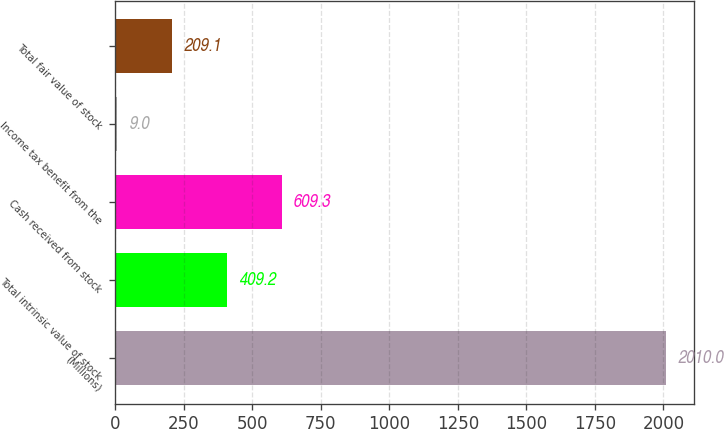Convert chart. <chart><loc_0><loc_0><loc_500><loc_500><bar_chart><fcel>(Millions)<fcel>Total intrinsic value of stock<fcel>Cash received from stock<fcel>Income tax benefit from the<fcel>Total fair value of stock<nl><fcel>2010<fcel>409.2<fcel>609.3<fcel>9<fcel>209.1<nl></chart> 